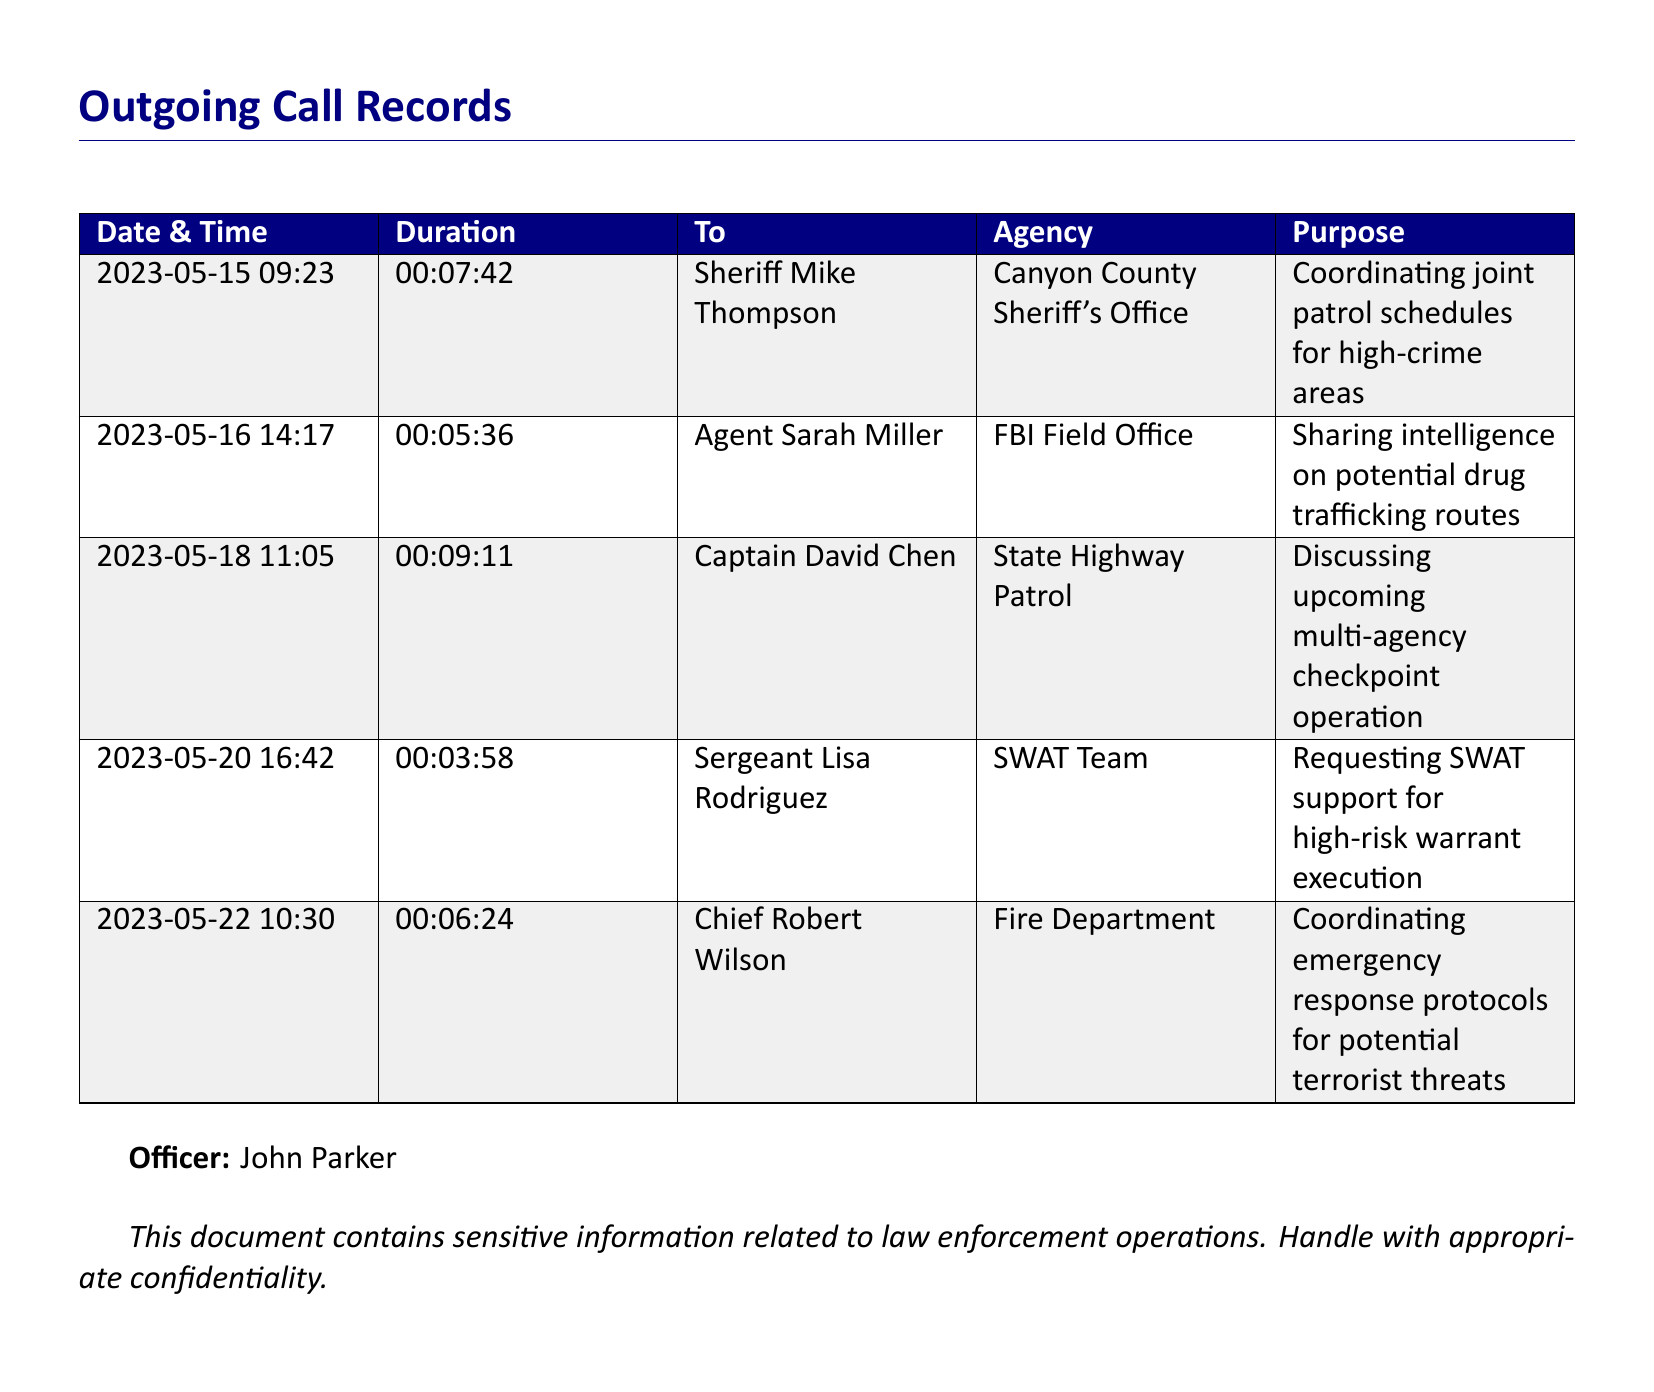What is the date of the call to Sheriff Mike Thompson? This is found in the first row under the 'Date & Time' column for the specific call.
Answer: 2023-05-15 How long was the call to Agent Sarah Miller? The duration of the call is listed in the second row under the 'Duration' column for that call.
Answer: 00:05:36 Which agency was contacted on 2023-05-20? This is given in the third column of the fourth row for that date.
Answer: SWAT Team What was the purpose of the call to Captain David Chen? The purpose is detailed in the fifth column of the third row.
Answer: Discussing upcoming multi-agency checkpoint operation Who is the officer making these calls? The officer's name is stated at the bottom of the document.
Answer: John Parker How many calls are made to law enforcement agencies in total? The total number of calls can be counted by the number of rows in the table excluding the header.
Answer: 5 What is the longest call duration recorded? The durations can be compared to find the longest call, specifically in the second column.
Answer: 00:09:11 Which call involved coordinating emergency response protocols? This is identified by looking at the purpose of the calls listed in the last row.
Answer: Chief Robert Wilson What day was the call made regarding drug trafficking routes? This date is found in the second row under the 'Date & Time' column related to the call about drug trafficking.
Answer: 2023-05-16 Which law enforcement agency was contacted for high-risk warrant execution? This information is detailed in the 'Agency' column of the fourth row.
Answer: SWAT Team 